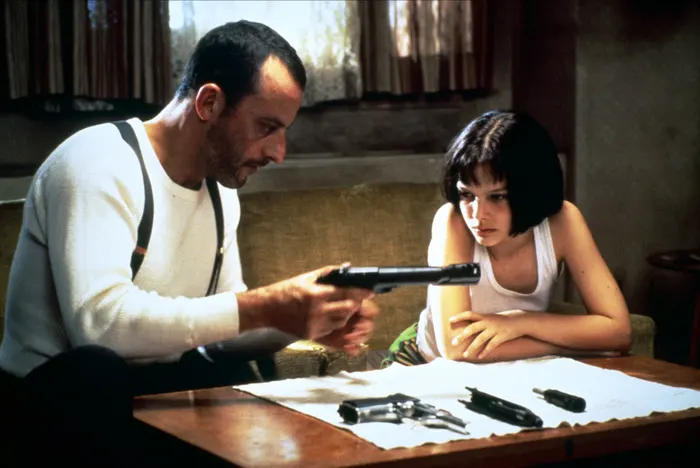Explain the visual content of the image in great detail. This image captures a pivotal scene from the film 'Léon: The Professional'. It shows Léon, played by Jean Reno, a professional hitman, instructing Mathilda, portrayed by Natalie Portman, a young girl who has become his protégée. They are seated at a rustic wooden table that holds multiple firearms, signifying the gravity of their training session. Léon, wearing a plain white tank top, suspenders, and a calm expression, is handling a black handgun, carefully pointing it at a piece of paper, potentially a target diagram, emphasizing his role as a mentor. Mathilda's attire mirrors Léon's, symbolizing her apprentice status, and her focused yet slightly anxious expression reflects her complex feelings about her new life. The modest room, with its beige walls and minimal furnishings, hints at Léon's spartan lifestyle and the secretive nature of his work. 